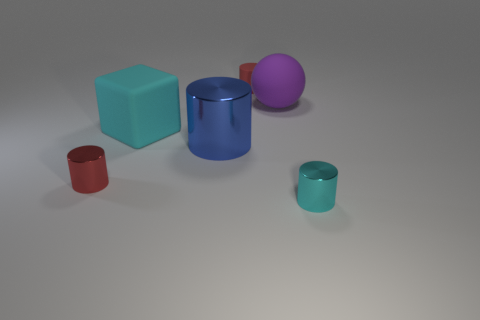Subtract all gray spheres. How many red cylinders are left? 2 Subtract all blue cylinders. How many cylinders are left? 3 Add 2 large blue shiny things. How many objects exist? 8 Subtract all red metal cylinders. How many cylinders are left? 3 Subtract all gray cylinders. Subtract all red cubes. How many cylinders are left? 4 Subtract 0 gray cylinders. How many objects are left? 6 Subtract all cylinders. How many objects are left? 2 Subtract all big cubes. Subtract all tiny purple balls. How many objects are left? 5 Add 1 blue shiny things. How many blue shiny things are left? 2 Add 5 large objects. How many large objects exist? 8 